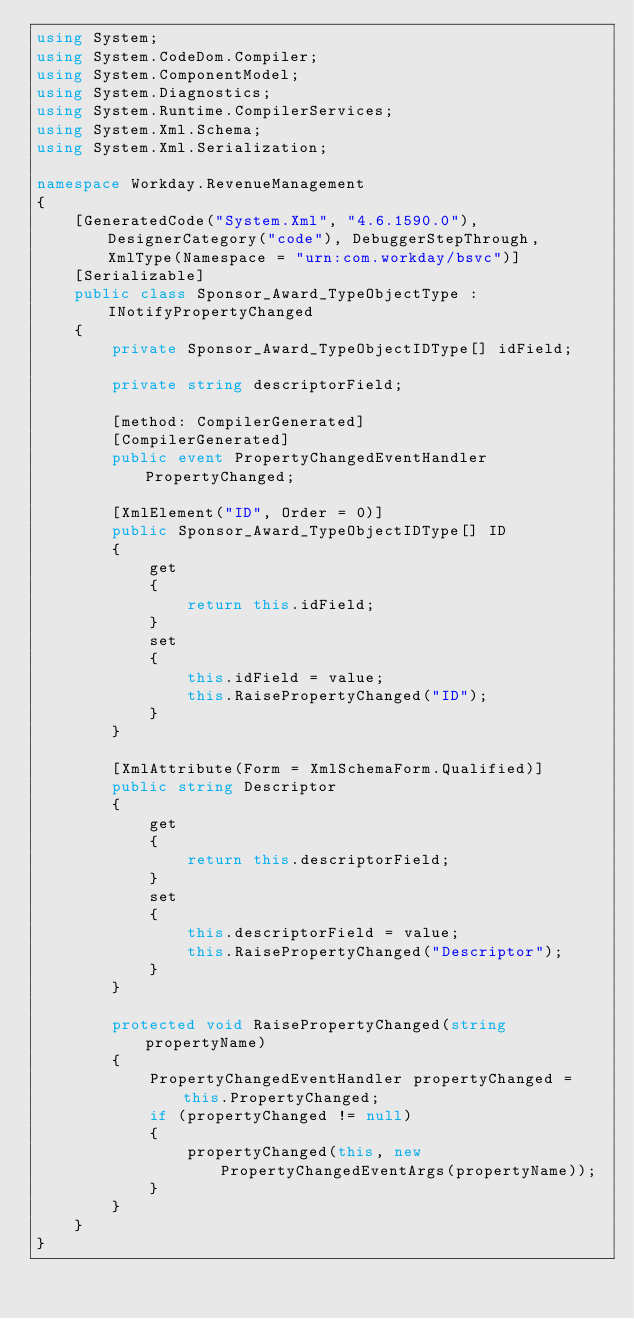Convert code to text. <code><loc_0><loc_0><loc_500><loc_500><_C#_>using System;
using System.CodeDom.Compiler;
using System.ComponentModel;
using System.Diagnostics;
using System.Runtime.CompilerServices;
using System.Xml.Schema;
using System.Xml.Serialization;

namespace Workday.RevenueManagement
{
	[GeneratedCode("System.Xml", "4.6.1590.0"), DesignerCategory("code"), DebuggerStepThrough, XmlType(Namespace = "urn:com.workday/bsvc")]
	[Serializable]
	public class Sponsor_Award_TypeObjectType : INotifyPropertyChanged
	{
		private Sponsor_Award_TypeObjectIDType[] idField;

		private string descriptorField;

		[method: CompilerGenerated]
		[CompilerGenerated]
		public event PropertyChangedEventHandler PropertyChanged;

		[XmlElement("ID", Order = 0)]
		public Sponsor_Award_TypeObjectIDType[] ID
		{
			get
			{
				return this.idField;
			}
			set
			{
				this.idField = value;
				this.RaisePropertyChanged("ID");
			}
		}

		[XmlAttribute(Form = XmlSchemaForm.Qualified)]
		public string Descriptor
		{
			get
			{
				return this.descriptorField;
			}
			set
			{
				this.descriptorField = value;
				this.RaisePropertyChanged("Descriptor");
			}
		}

		protected void RaisePropertyChanged(string propertyName)
		{
			PropertyChangedEventHandler propertyChanged = this.PropertyChanged;
			if (propertyChanged != null)
			{
				propertyChanged(this, new PropertyChangedEventArgs(propertyName));
			}
		}
	}
}
</code> 